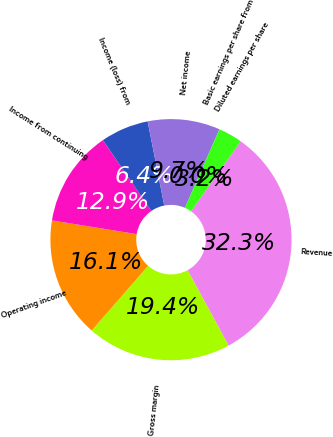Convert chart. <chart><loc_0><loc_0><loc_500><loc_500><pie_chart><fcel>Revenue<fcel>Gross margin<fcel>Operating income<fcel>Income from continuing<fcel>Income (loss) from<fcel>Net income<fcel>Basic earnings per share from<fcel>Diluted earnings per share<nl><fcel>32.26%<fcel>19.35%<fcel>16.13%<fcel>12.9%<fcel>6.45%<fcel>9.68%<fcel>0.0%<fcel>3.23%<nl></chart> 